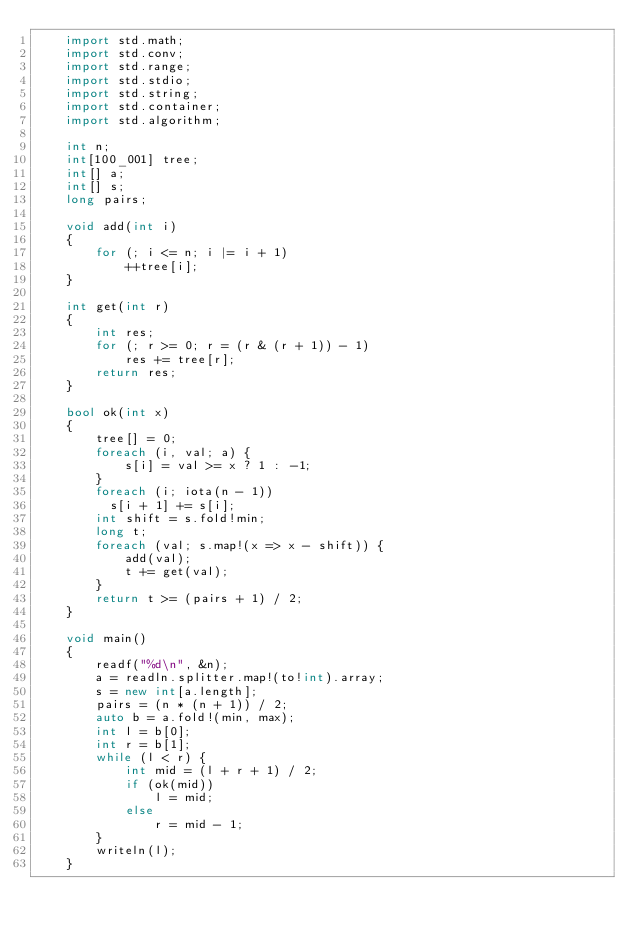<code> <loc_0><loc_0><loc_500><loc_500><_D_>    import std.math;
    import std.conv;
    import std.range;
    import std.stdio;
    import std.string;
    import std.container;
    import std.algorithm;
     
    int n;
    int[100_001] tree;
    int[] a;
    int[] s;
    long pairs;
     
    void add(int i)
    {
        for (; i <= n; i |= i + 1)
            ++tree[i];
    }
     
    int get(int r)
    {
        int res;
        for (; r >= 0; r = (r & (r + 1)) - 1)
            res += tree[r];
        return res;
    }
     
    bool ok(int x)
    {
        tree[] = 0;
        foreach (i, val; a) {
            s[i] = val >= x ? 1 : -1;
        }
        foreach (i; iota(n - 1))
          s[i + 1] += s[i];
        int shift = s.fold!min;
        long t;
        foreach (val; s.map!(x => x - shift)) {
            add(val);
            t += get(val);
        }
        return t >= (pairs + 1) / 2;
    }
     
    void main()
    {
        readf("%d\n", &n);
        a = readln.splitter.map!(to!int).array;
        s = new int[a.length];
        pairs = (n * (n + 1)) / 2;
        auto b = a.fold!(min, max);
        int l = b[0];
        int r = b[1];
        while (l < r) {
            int mid = (l + r + 1) / 2;
            if (ok(mid))
                l = mid;
            else
                r = mid - 1;
        }
        writeln(l);
    }
</code> 